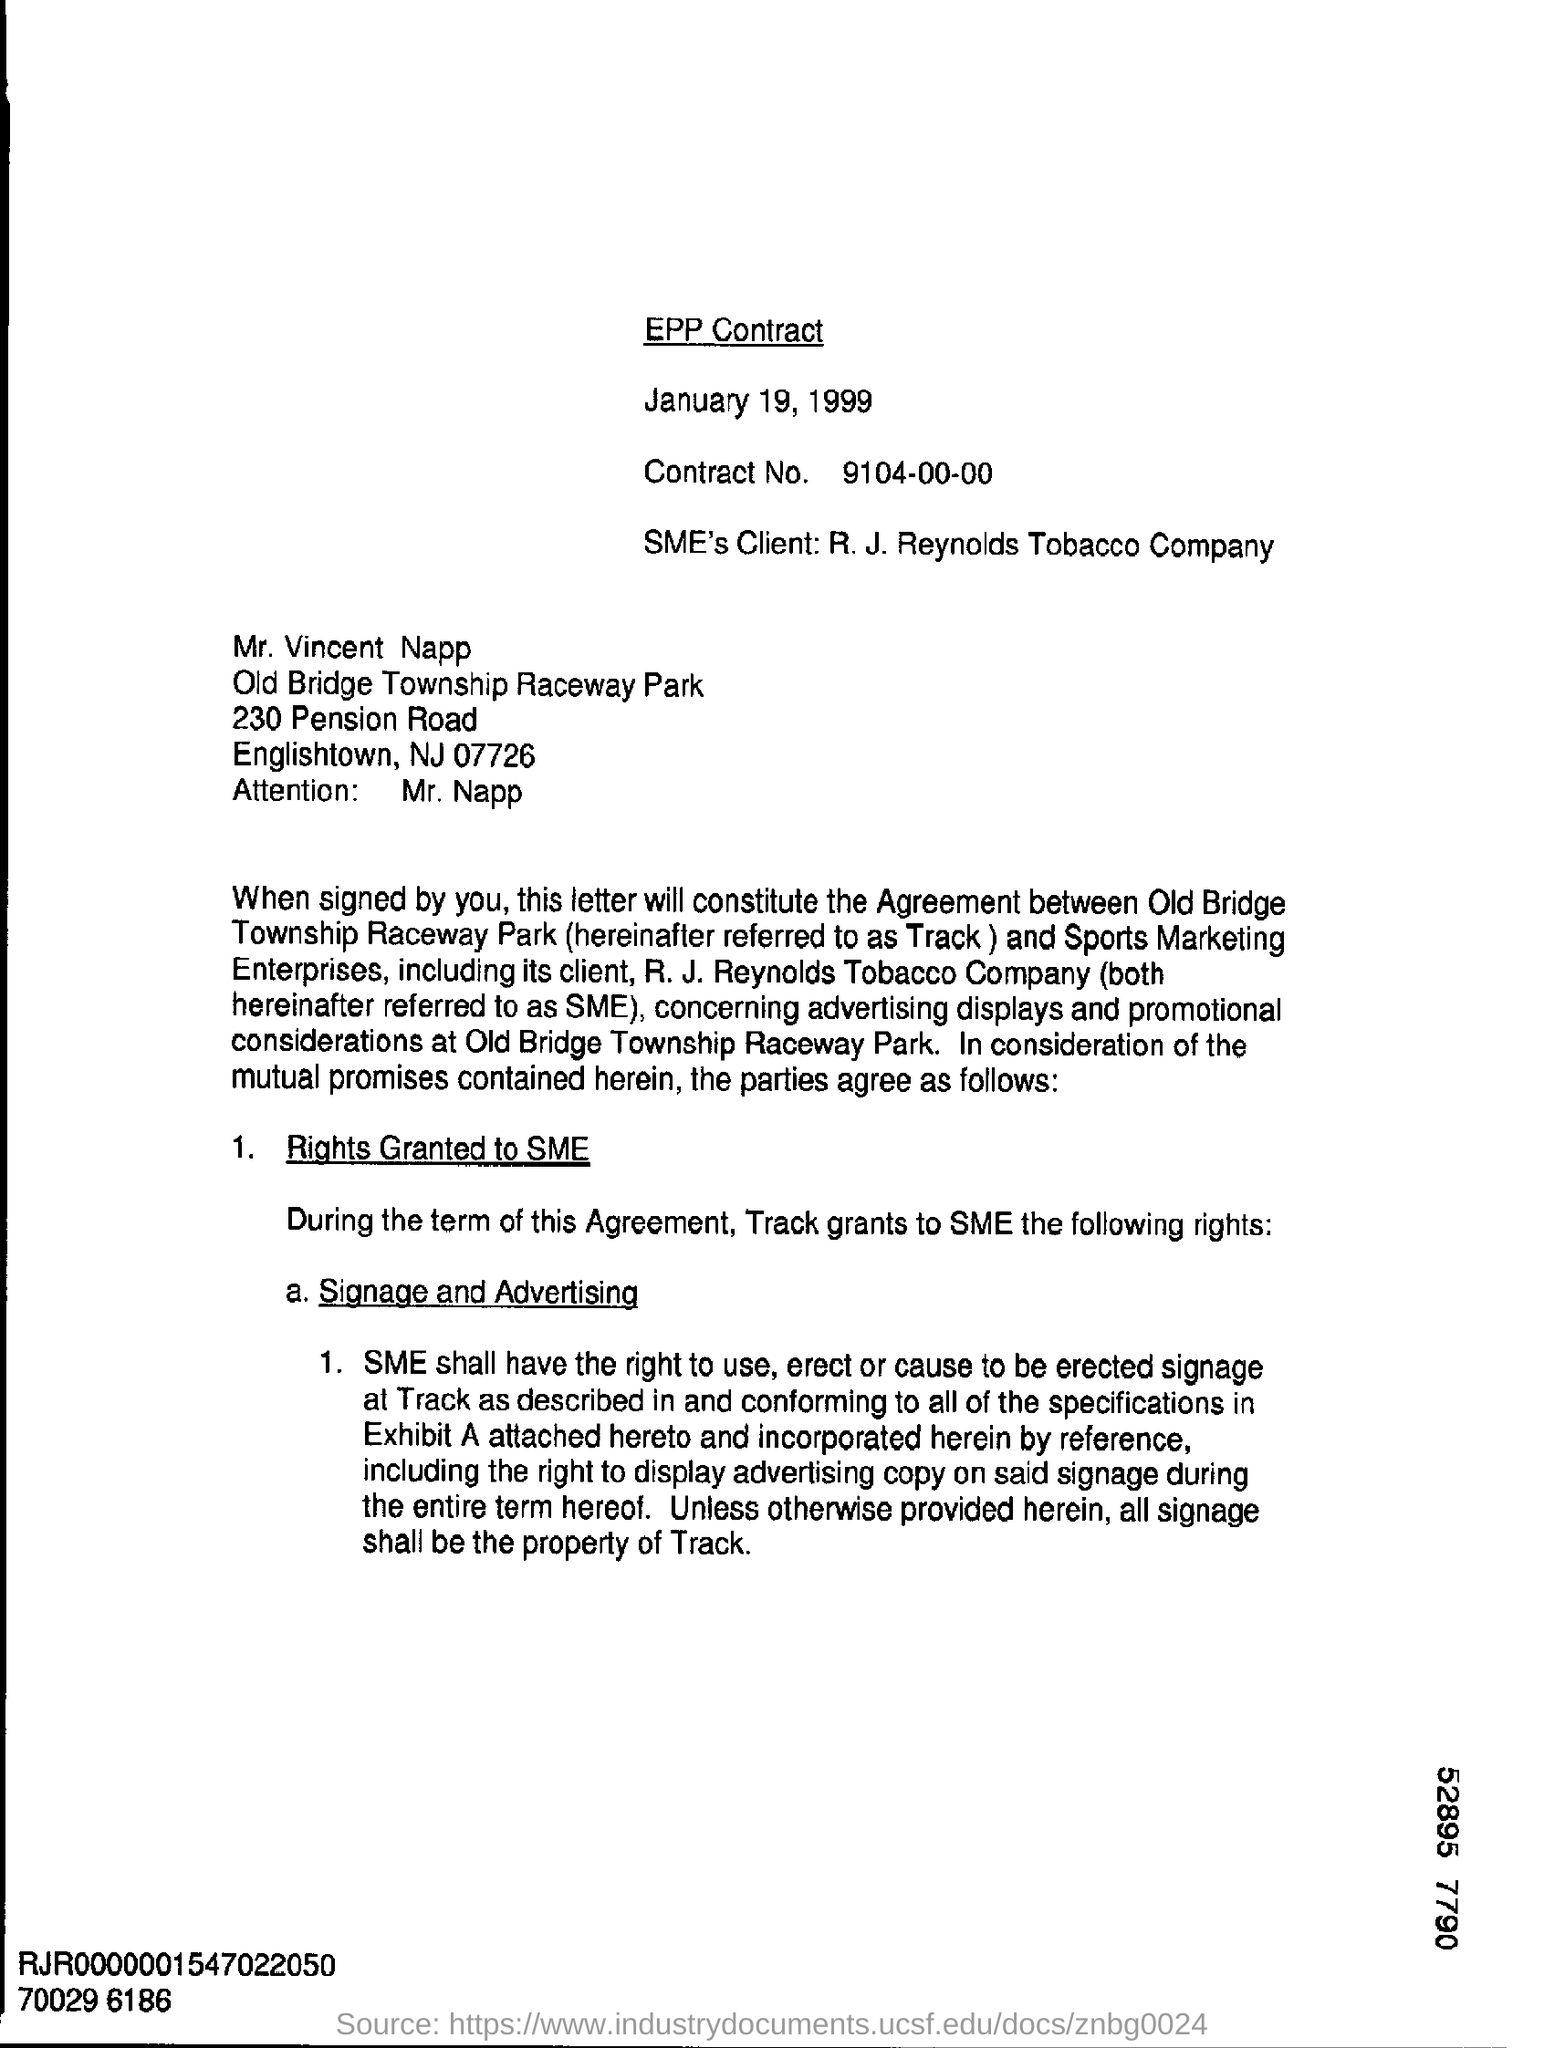Outline some significant characteristics in this image. The contract number is 9104-00-00. Track is referred to as Old Bridge Township Raceway Park. The name of the road mentioned in this letter is Pension Road. The date of the contract is January 19, 1999. To whom the letter is addressed is Mr. Vincent Napp... 